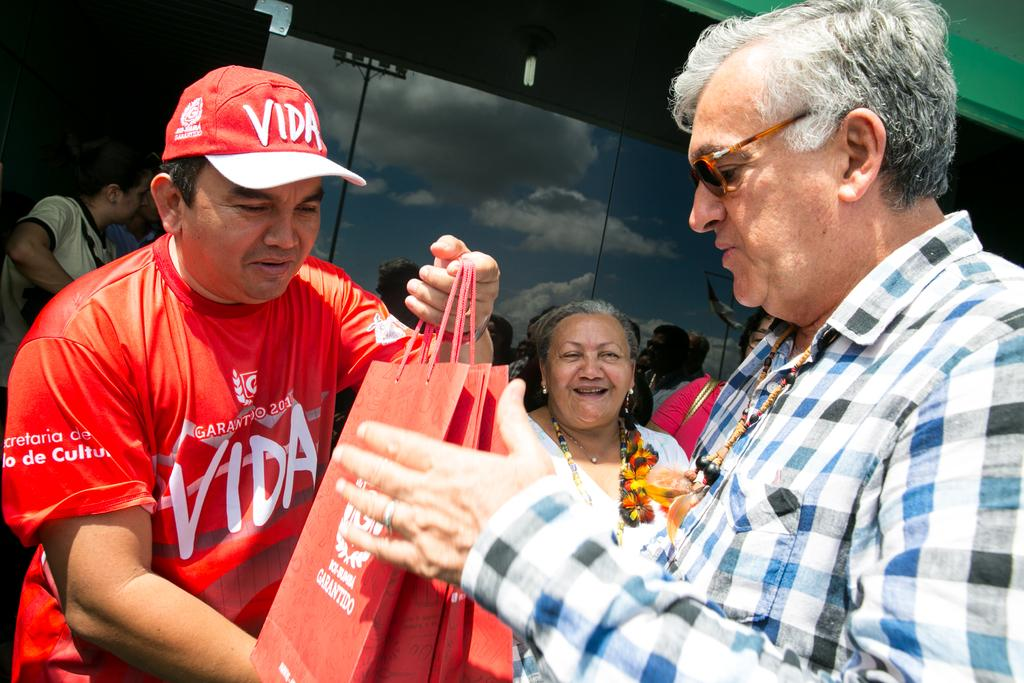What is the man in the image doing? The man in the image is holding bags. Can you describe the other people in the image? There are people in the image, but their specific actions or appearances are not mentioned in the facts. What can be seen reflected on a glass surface in the image? The reflection of the sky and clouds can be seen on a glass surface in the image. What type of snake is slithering across the man's arm in the image? There is no snake present in the image; the man is holding bags. 